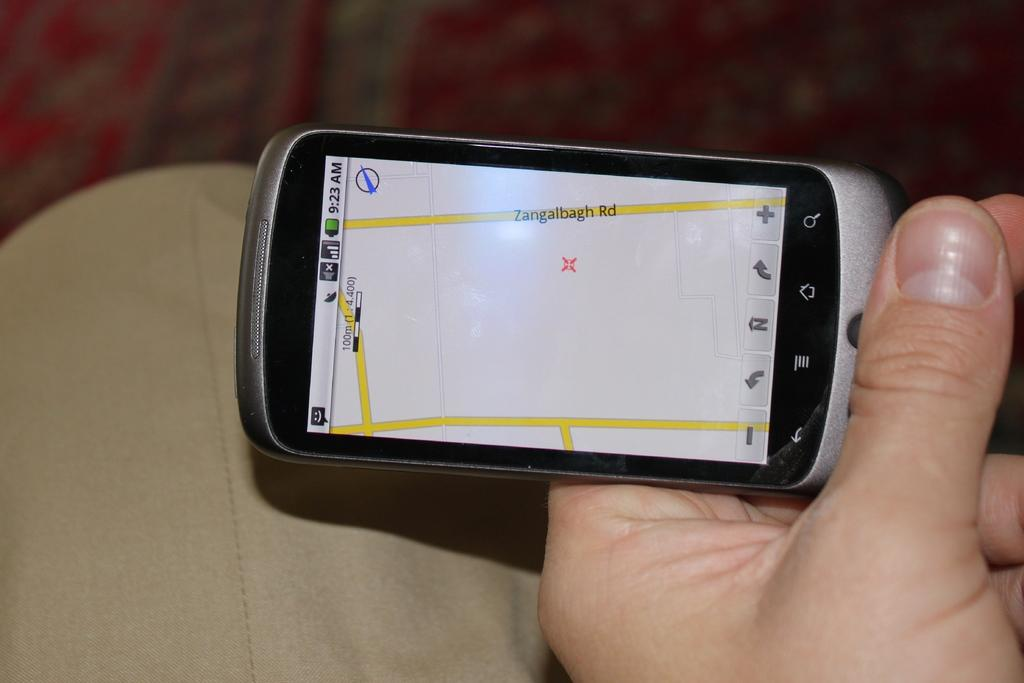<image>
Share a concise interpretation of the image provided. someone is holding a phone with a map on it with a red x near Zangalbagh rd 